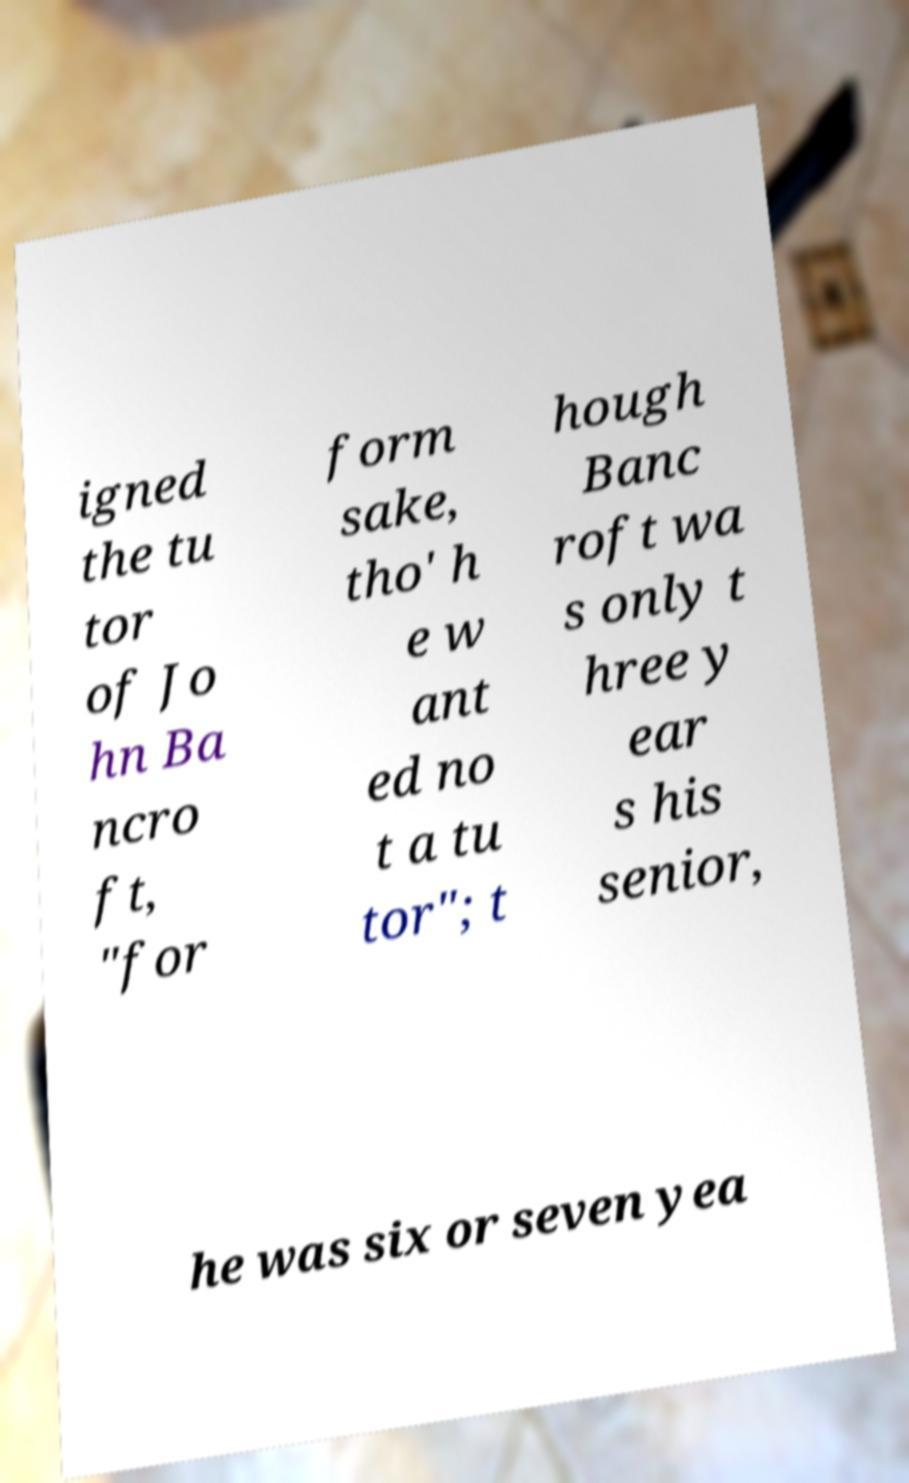Can you accurately transcribe the text from the provided image for me? igned the tu tor of Jo hn Ba ncro ft, "for form sake, tho' h e w ant ed no t a tu tor"; t hough Banc roft wa s only t hree y ear s his senior, he was six or seven yea 